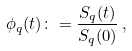Convert formula to latex. <formula><loc_0><loc_0><loc_500><loc_500>\phi _ { q } ( t ) \colon = \frac { S _ { q } ( t ) } { S _ { q } ( 0 ) } \, ,</formula> 